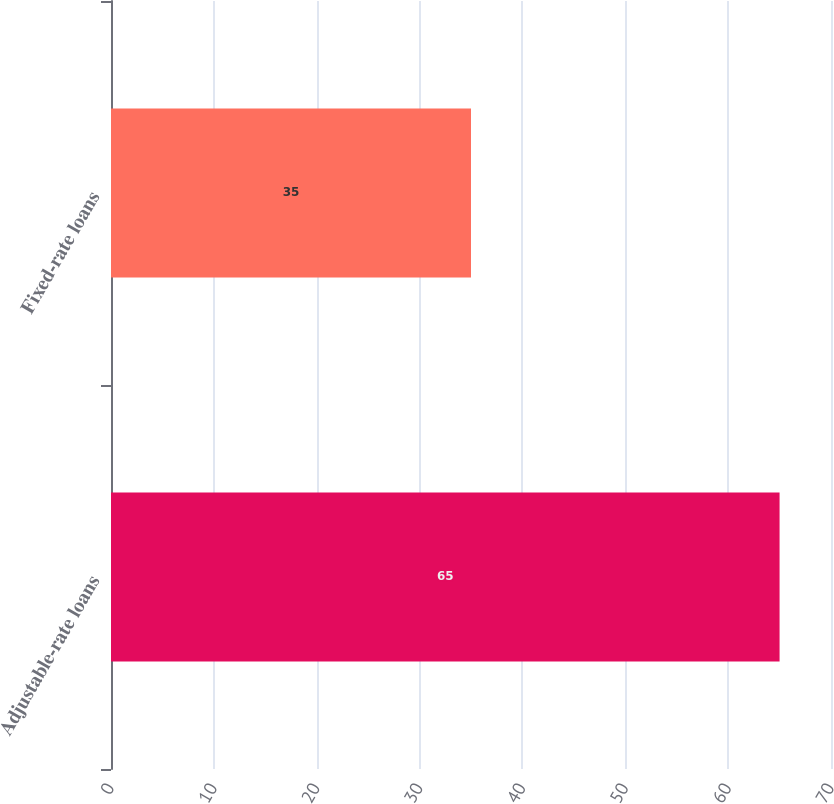<chart> <loc_0><loc_0><loc_500><loc_500><bar_chart><fcel>Adjustable-rate loans<fcel>Fixed-rate loans<nl><fcel>65<fcel>35<nl></chart> 